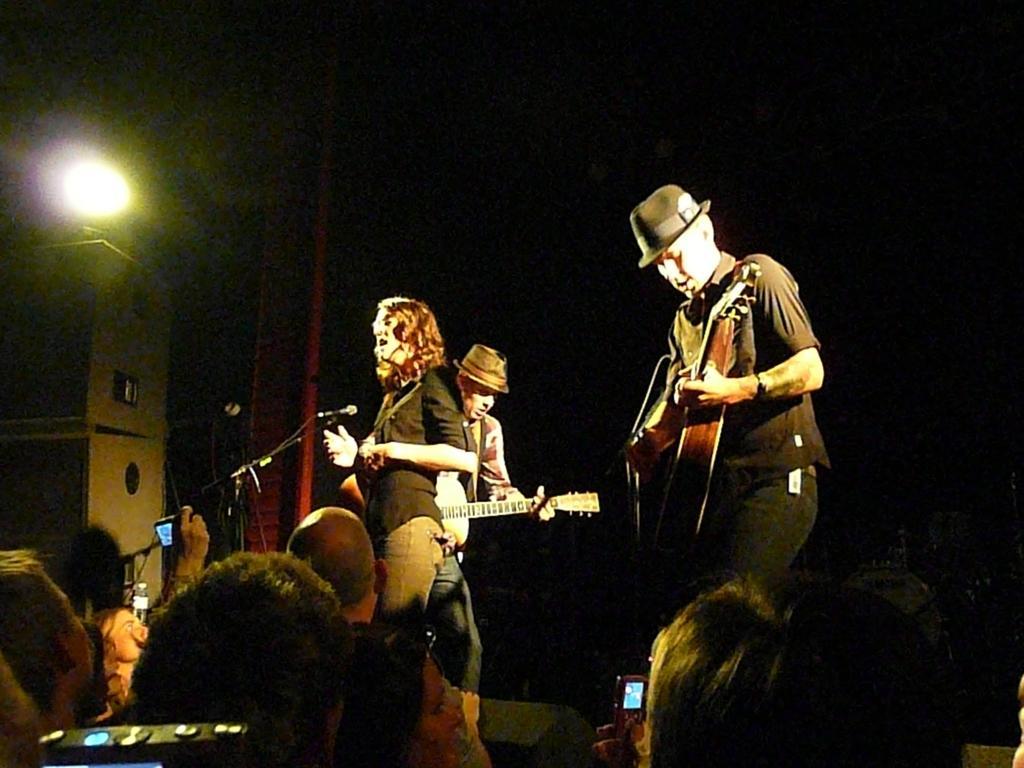Could you give a brief overview of what you see in this image? The picture is taken on the stage where three people are performing and standing and at the right corner in the picture a man in black dress is wearing a hat and playing guitar and at the left corner there is a box and light on and in front of him there is a crowd holding phones in their hands. 